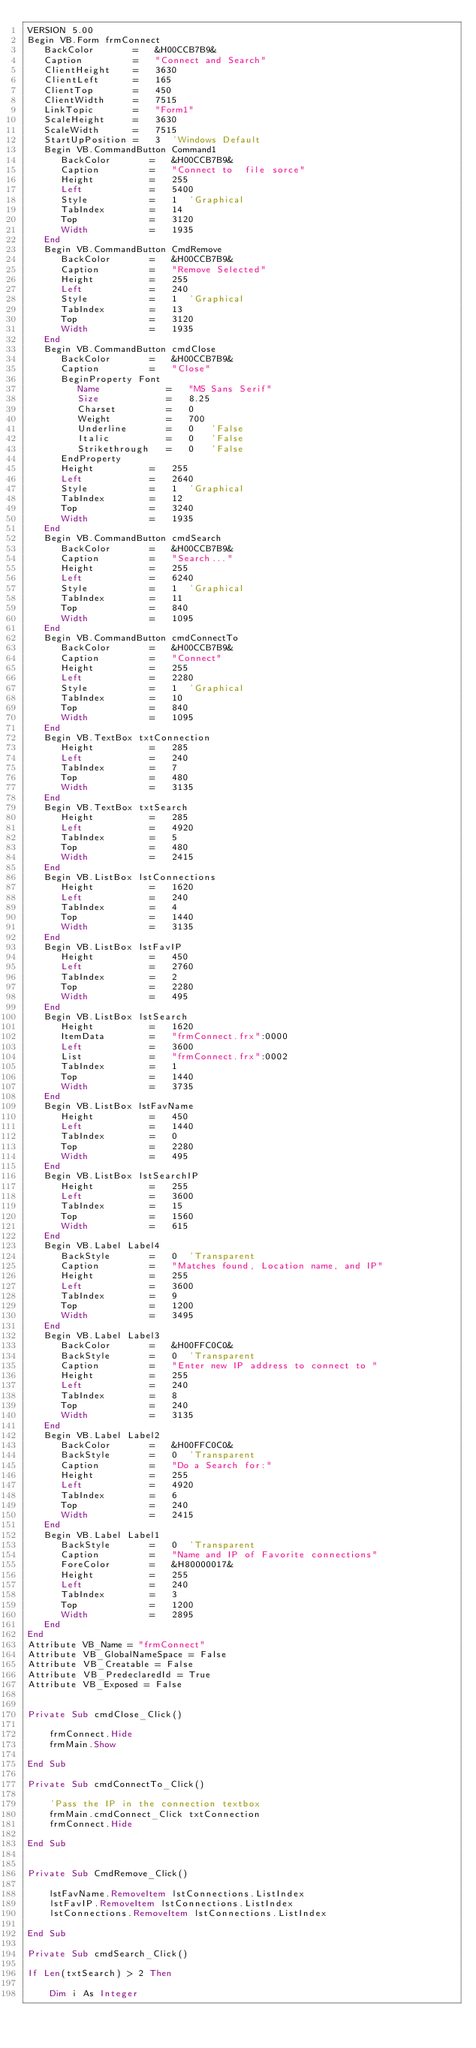Convert code to text. <code><loc_0><loc_0><loc_500><loc_500><_VisualBasic_>VERSION 5.00
Begin VB.Form frmConnect 
   BackColor       =   &H00CCB7B9&
   Caption         =   "Connect and Search"
   ClientHeight    =   3630
   ClientLeft      =   165
   ClientTop       =   450
   ClientWidth     =   7515
   LinkTopic       =   "Form1"
   ScaleHeight     =   3630
   ScaleWidth      =   7515
   StartUpPosition =   3  'Windows Default
   Begin VB.CommandButton Command1 
      BackColor       =   &H00CCB7B9&
      Caption         =   "Connect to  file sorce"
      Height          =   255
      Left            =   5400
      Style           =   1  'Graphical
      TabIndex        =   14
      Top             =   3120
      Width           =   1935
   End
   Begin VB.CommandButton CmdRemove 
      BackColor       =   &H00CCB7B9&
      Caption         =   "Remove Selected"
      Height          =   255
      Left            =   240
      Style           =   1  'Graphical
      TabIndex        =   13
      Top             =   3120
      Width           =   1935
   End
   Begin VB.CommandButton cmdClose 
      BackColor       =   &H00CCB7B9&
      Caption         =   "Close"
      BeginProperty Font 
         Name            =   "MS Sans Serif"
         Size            =   8.25
         Charset         =   0
         Weight          =   700
         Underline       =   0   'False
         Italic          =   0   'False
         Strikethrough   =   0   'False
      EndProperty
      Height          =   255
      Left            =   2640
      Style           =   1  'Graphical
      TabIndex        =   12
      Top             =   3240
      Width           =   1935
   End
   Begin VB.CommandButton cmdSearch 
      BackColor       =   &H00CCB7B9&
      Caption         =   "Search..."
      Height          =   255
      Left            =   6240
      Style           =   1  'Graphical
      TabIndex        =   11
      Top             =   840
      Width           =   1095
   End
   Begin VB.CommandButton cmdConnectTo 
      BackColor       =   &H00CCB7B9&
      Caption         =   "Connect"
      Height          =   255
      Left            =   2280
      Style           =   1  'Graphical
      TabIndex        =   10
      Top             =   840
      Width           =   1095
   End
   Begin VB.TextBox txtConnection 
      Height          =   285
      Left            =   240
      TabIndex        =   7
      Top             =   480
      Width           =   3135
   End
   Begin VB.TextBox txtSearch 
      Height          =   285
      Left            =   4920
      TabIndex        =   5
      Top             =   480
      Width           =   2415
   End
   Begin VB.ListBox lstConnections 
      Height          =   1620
      Left            =   240
      TabIndex        =   4
      Top             =   1440
      Width           =   3135
   End
   Begin VB.ListBox lstFavIP 
      Height          =   450
      Left            =   2760
      TabIndex        =   2
      Top             =   2280
      Width           =   495
   End
   Begin VB.ListBox lstSearch 
      Height          =   1620
      ItemData        =   "frmConnect.frx":0000
      Left            =   3600
      List            =   "frmConnect.frx":0002
      TabIndex        =   1
      Top             =   1440
      Width           =   3735
   End
   Begin VB.ListBox lstFavName 
      Height          =   450
      Left            =   1440
      TabIndex        =   0
      Top             =   2280
      Width           =   495
   End
   Begin VB.ListBox lstSearchIP 
      Height          =   255
      Left            =   3600
      TabIndex        =   15
      Top             =   1560
      Width           =   615
   End
   Begin VB.Label Label4 
      BackStyle       =   0  'Transparent
      Caption         =   "Matches found, Location name, and IP"
      Height          =   255
      Left            =   3600
      TabIndex        =   9
      Top             =   1200
      Width           =   3495
   End
   Begin VB.Label Label3 
      BackColor       =   &H00FFC0C0&
      BackStyle       =   0  'Transparent
      Caption         =   "Enter new IP address to connect to "
      Height          =   255
      Left            =   240
      TabIndex        =   8
      Top             =   240
      Width           =   3135
   End
   Begin VB.Label Label2 
      BackColor       =   &H00FFC0C0&
      BackStyle       =   0  'Transparent
      Caption         =   "Do a Search for:"
      Height          =   255
      Left            =   4920
      TabIndex        =   6
      Top             =   240
      Width           =   2415
   End
   Begin VB.Label Label1 
      BackStyle       =   0  'Transparent
      Caption         =   "Name and IP of Favorite connections"
      ForeColor       =   &H80000017&
      Height          =   255
      Left            =   240
      TabIndex        =   3
      Top             =   1200
      Width           =   2895
   End
End
Attribute VB_Name = "frmConnect"
Attribute VB_GlobalNameSpace = False
Attribute VB_Creatable = False
Attribute VB_PredeclaredId = True
Attribute VB_Exposed = False


Private Sub cmdClose_Click()
    
    frmConnect.Hide
    frmMain.Show
    
End Sub

Private Sub cmdConnectTo_Click()

    'Pass the IP in the connection textbox
    frmMain.cmdConnect_Click txtConnection
    frmConnect.Hide
    
End Sub


Private Sub CmdRemove_Click()
    
    lstFavName.RemoveItem lstConnections.ListIndex
    lstFavIP.RemoveItem lstConnections.ListIndex
    lstConnections.RemoveItem lstConnections.ListIndex
    
End Sub

Private Sub cmdSearch_Click()

If Len(txtSearch) > 2 Then

    Dim i As Integer
</code> 